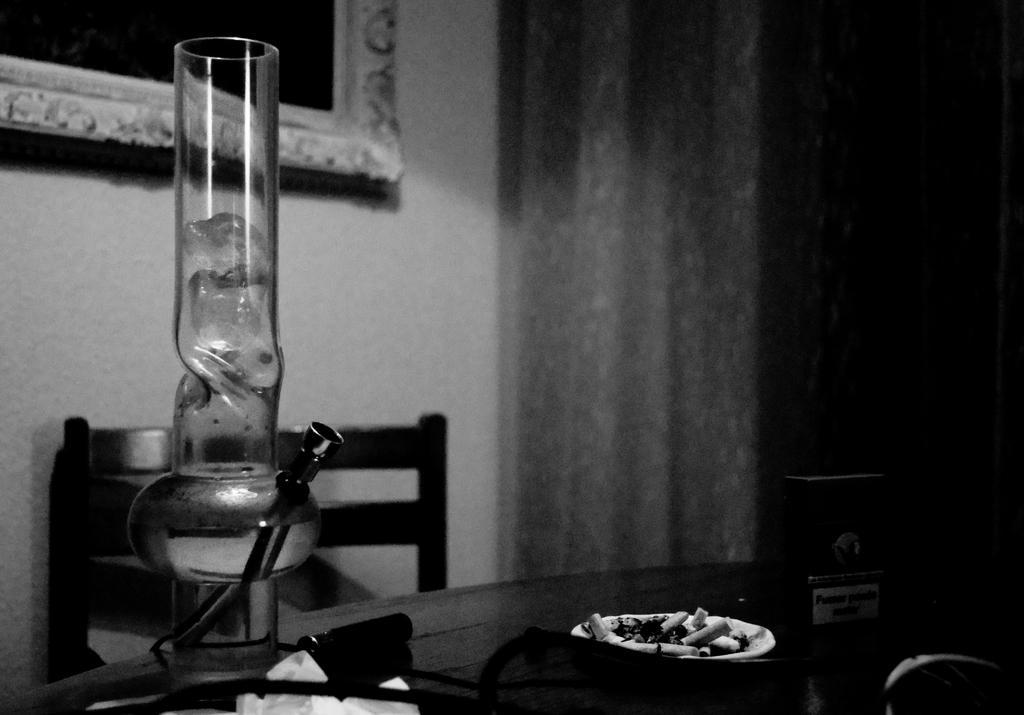In one or two sentences, can you explain what this image depicts? This is a black and white image where we can see a glass object, a plate with ash and few more objects are placed on the table. Here we can see a chair, a photo frame on the wall and curtains in the background. 